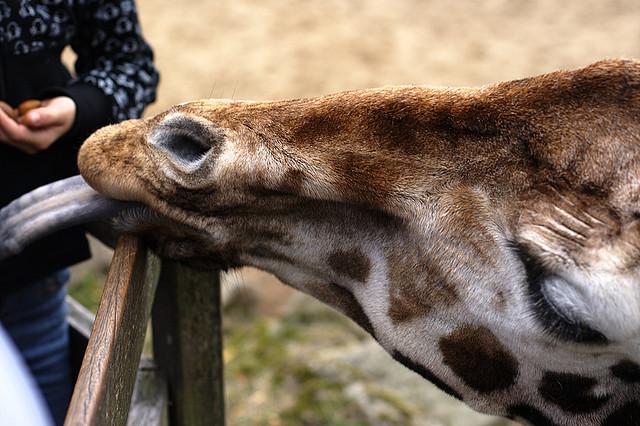Are the animals eyes open?
Concise answer only. No. Is anyone feeding the giraffe?
Short answer required. Yes. What is the giraffe's chin resting on?
Answer briefly. Fence. 